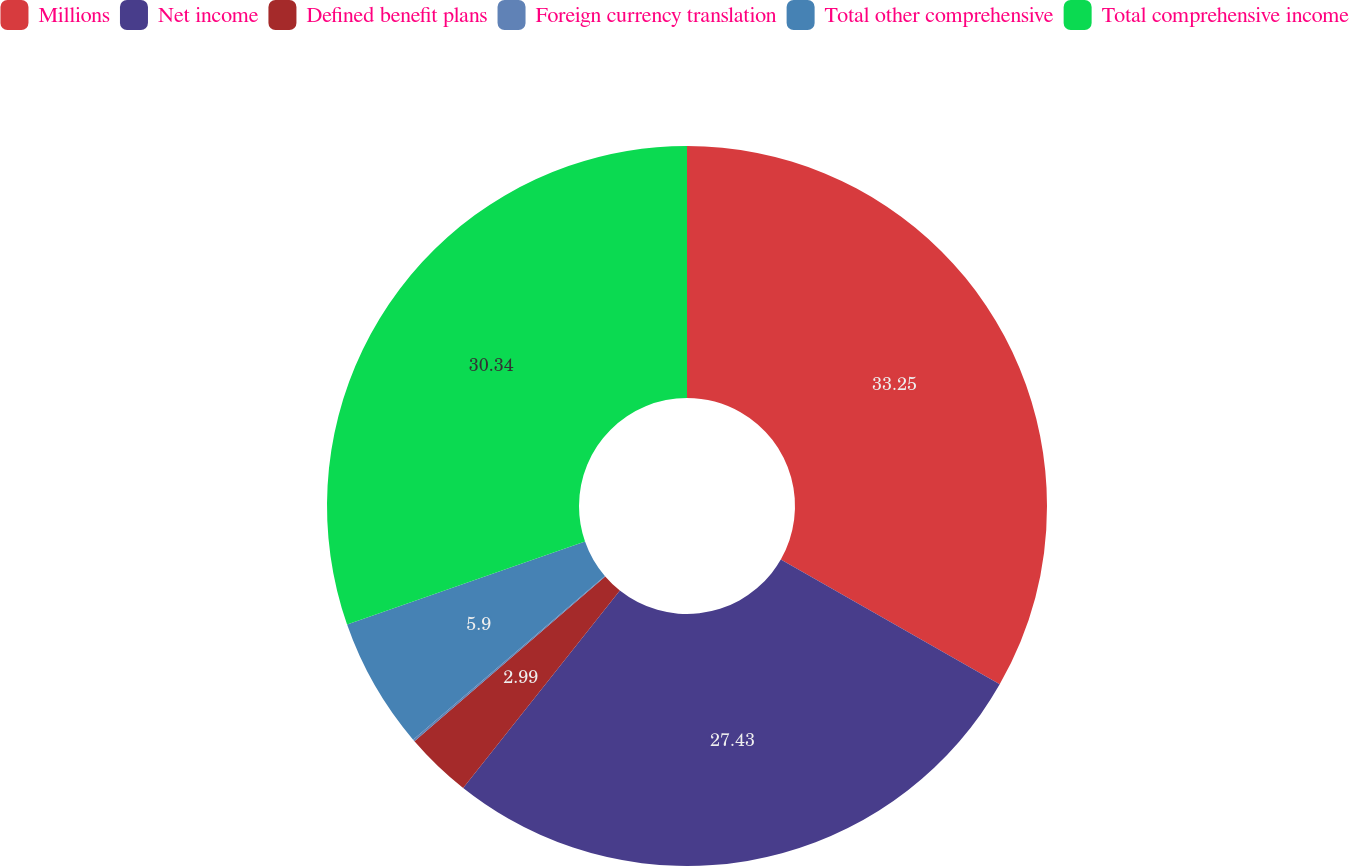Convert chart to OTSL. <chart><loc_0><loc_0><loc_500><loc_500><pie_chart><fcel>Millions<fcel>Net income<fcel>Defined benefit plans<fcel>Foreign currency translation<fcel>Total other comprehensive<fcel>Total comprehensive income<nl><fcel>33.25%<fcel>27.43%<fcel>2.99%<fcel>0.09%<fcel>5.9%<fcel>30.34%<nl></chart> 